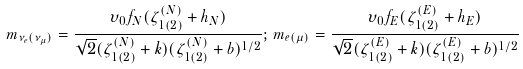Convert formula to latex. <formula><loc_0><loc_0><loc_500><loc_500>m _ { \nu _ { e } ( \nu _ { \mu } ) } = \frac { \upsilon _ { 0 } f _ { N } ( \zeta ^ { ( N ) } _ { 1 ( 2 ) } + h _ { N } ) } { \sqrt { 2 } ( \zeta ^ { ( N ) } _ { 1 ( 2 ) } + k ) ( \zeta ^ { ( N ) } _ { 1 ( 2 ) } + b ) ^ { 1 / 2 } } ; \, m _ { e ( \mu ) } = \frac { \upsilon _ { 0 } f _ { E } ( \zeta ^ { ( E ) } _ { 1 ( 2 ) } + h _ { E } ) } { \sqrt { 2 } ( \zeta ^ { ( E ) } _ { 1 ( 2 ) } + k ) ( \zeta ^ { ( E ) } _ { 1 ( 2 ) } + b ) ^ { 1 / 2 } }</formula> 